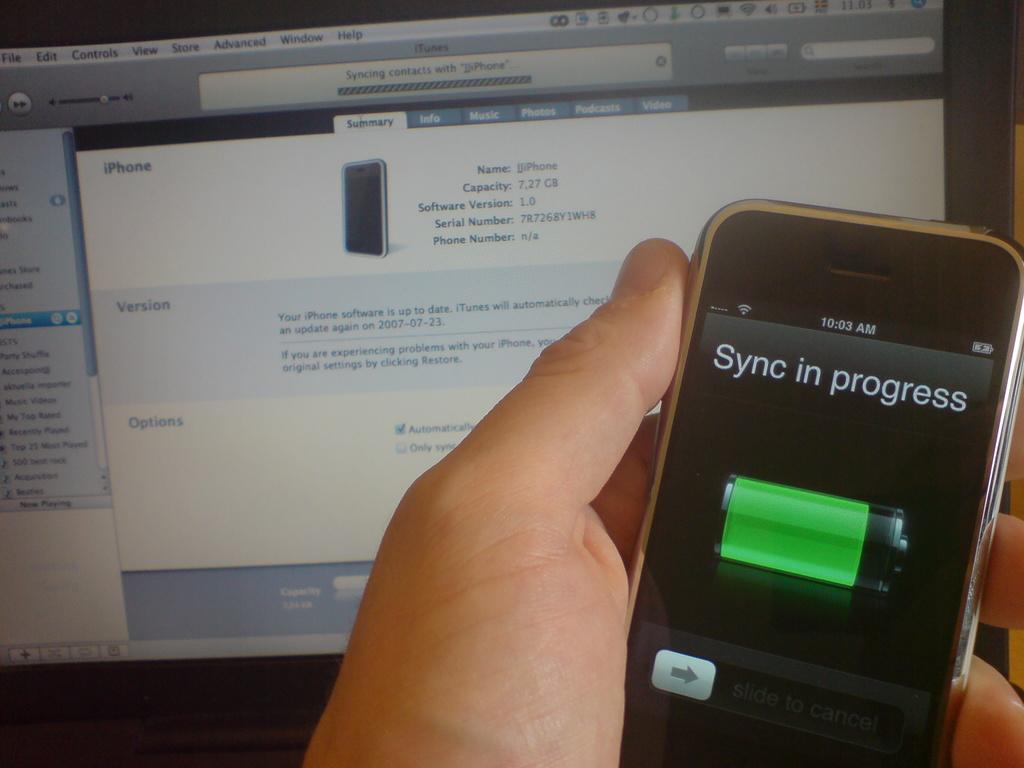What is currently in progress on the phone?
Keep it short and to the point. Sync. What kind of phone?
Your response must be concise. Iphone. 